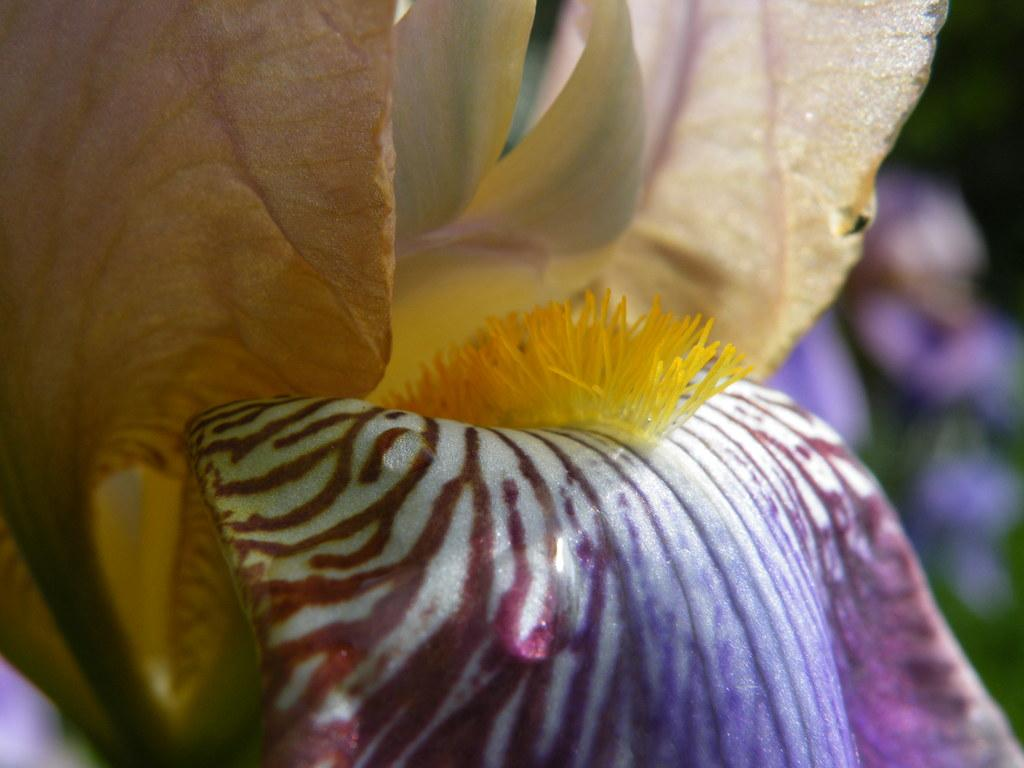What type of plants can be seen in the image? There are flowering plants in the image. Can you describe the setting where the plants are located? The image may have been taken in a garden. How many parcels are visible in the image? There are no parcels present in the image. Are there any bikes visible in the image? There is no mention of bikes in the provided facts, and therefore no such objects can be observed in the image. 